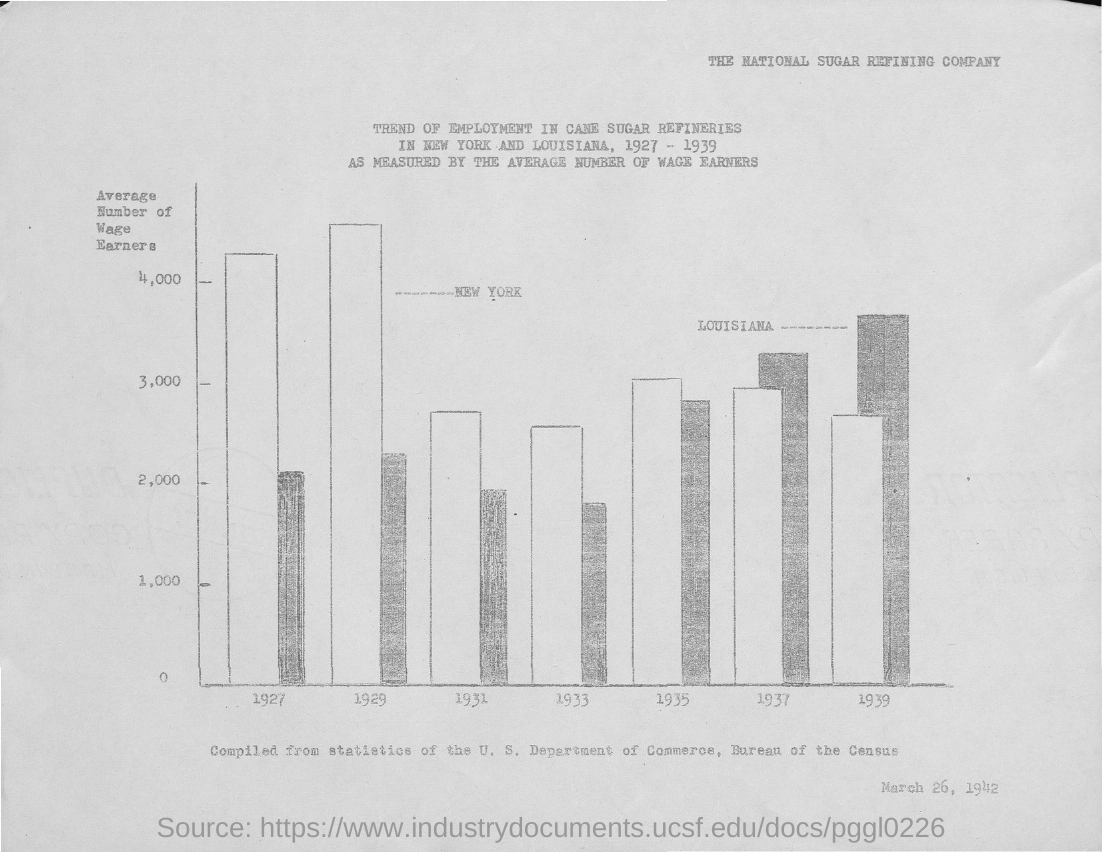What is the date mentioned at the bottom of the document?
Give a very brief answer. March 26, 1942. What is plotted on the y-axis?
Your answer should be compact. Average number of wage earners. What is the name of the company?
Give a very brief answer. The National Sugar Refining Company. 